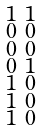Convert formula to latex. <formula><loc_0><loc_0><loc_500><loc_500>\begin{smallmatrix} 1 & 1 \\ 0 & 0 \\ 0 & 0 \\ 0 & 1 \\ 1 & 0 \\ 1 & 0 \\ 1 & 0 \end{smallmatrix}</formula> 